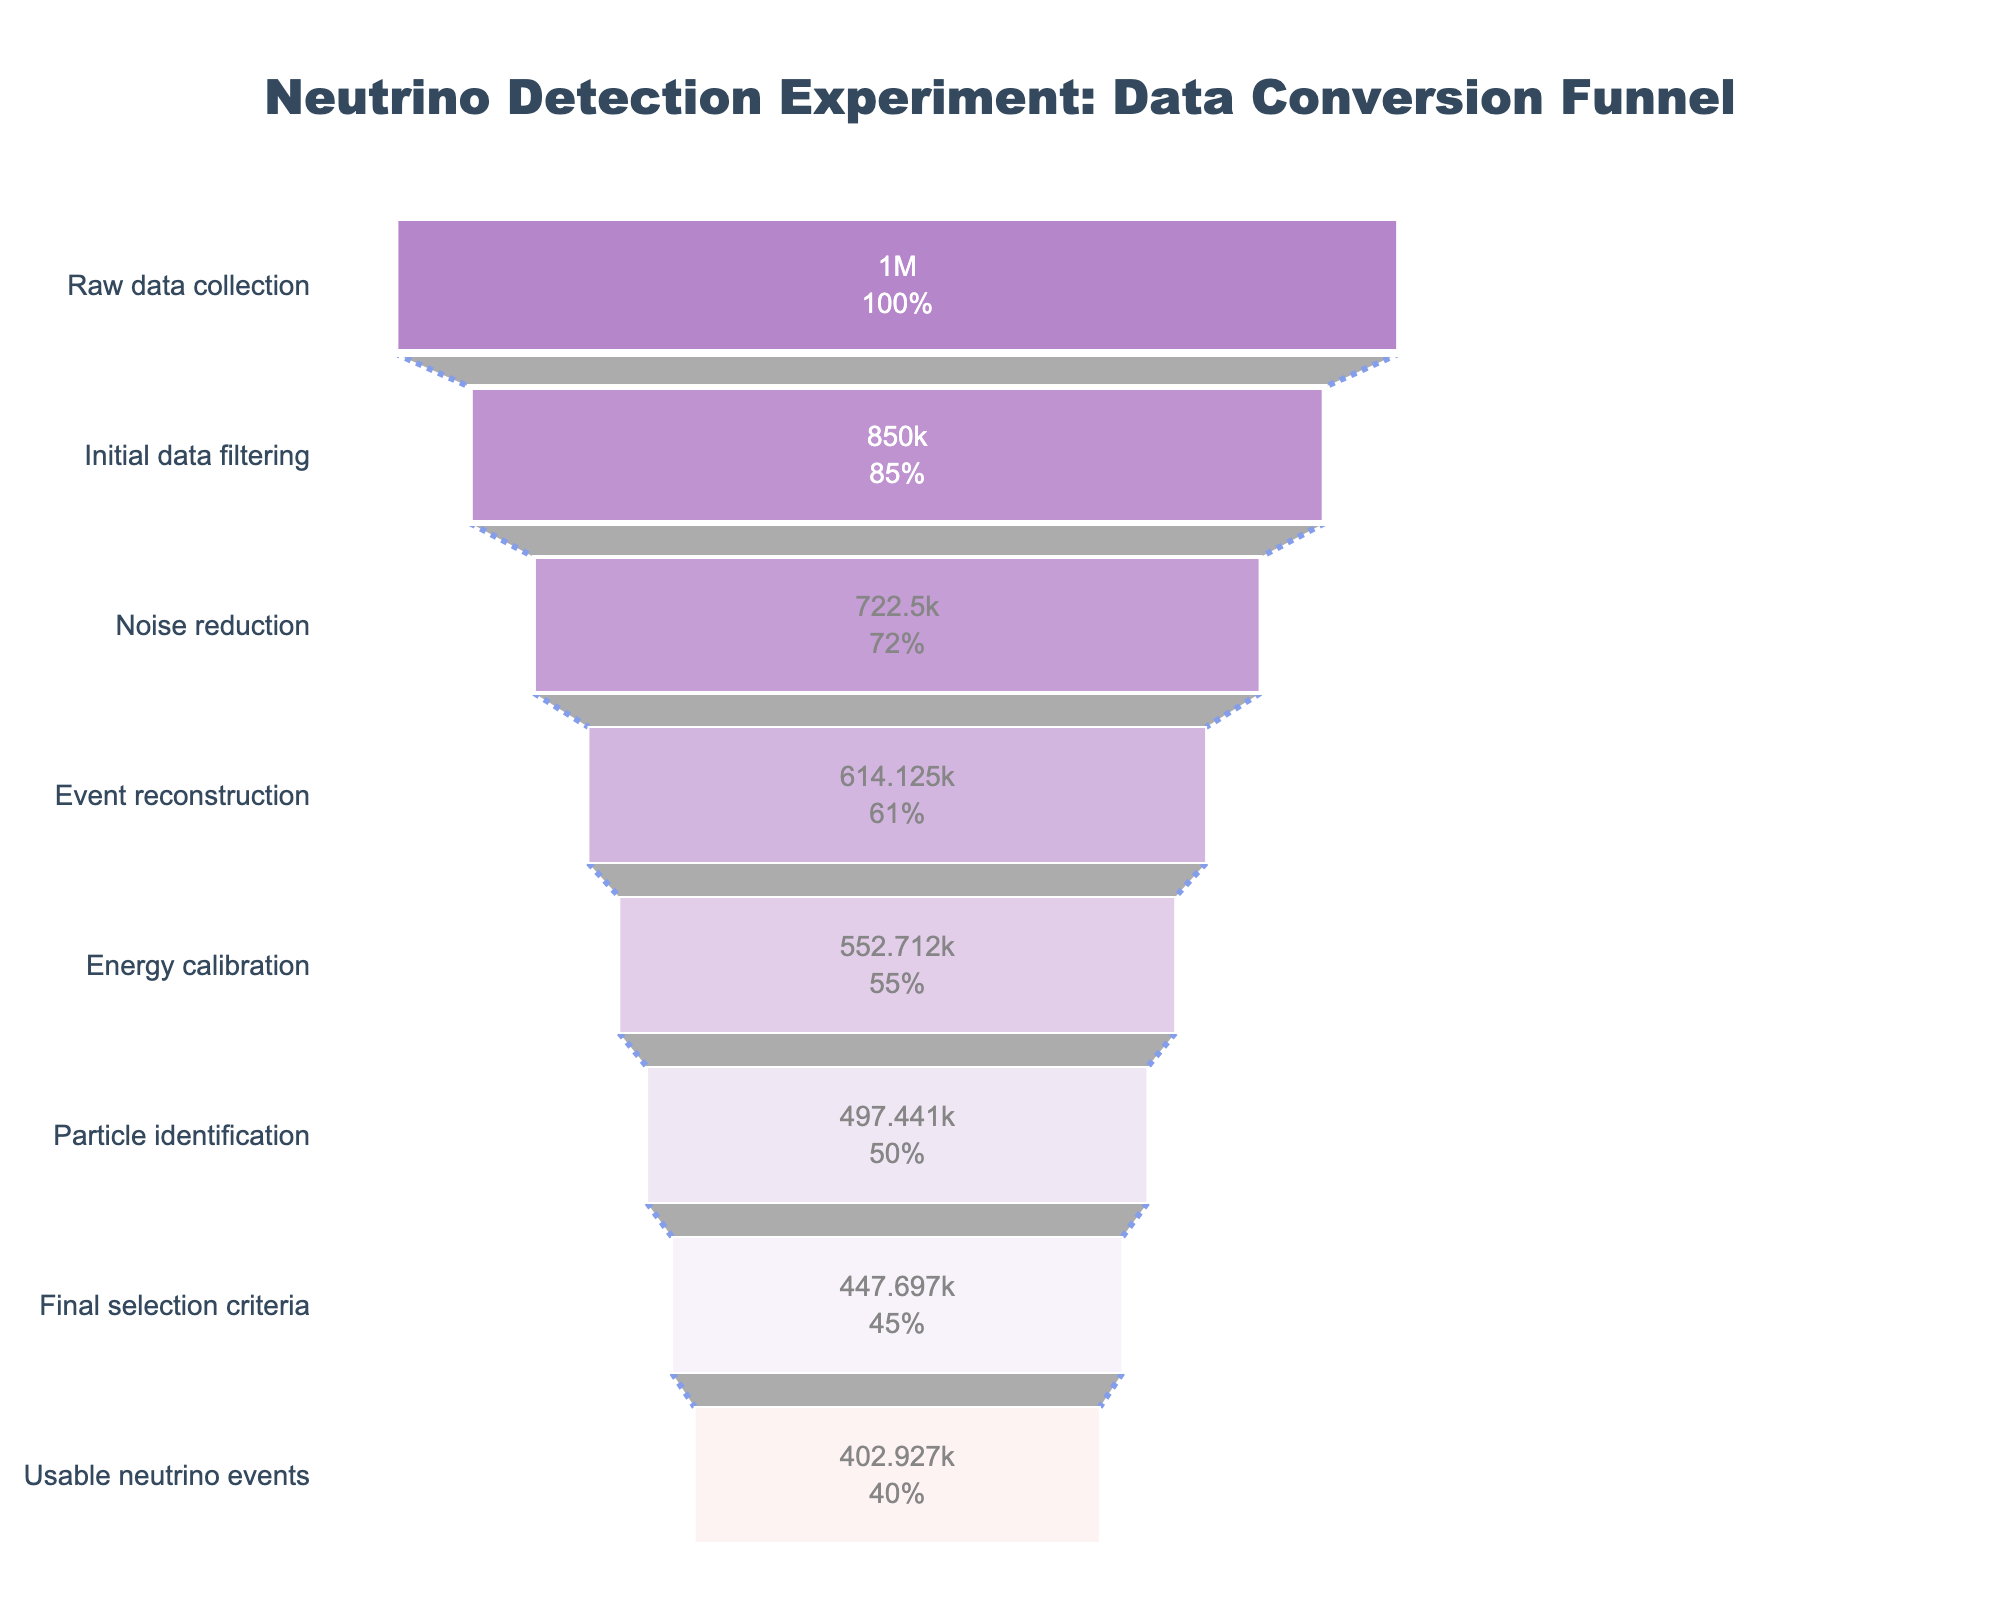what is the percentage of usable neutrino events compared to the raw data collection? To determine this, we can look at the last stage in the funnel chart, which shows the usable neutrino events. The percentage of usable neutrino events is 40.29% as indicated in the chart.
Answer: 40.29% How many events were retained after initial data filtering? According to the funnel chart, after the initial data filtering stage, 850,000 events were retained.
Answer: 850,000 What stage has the largest drop in the number of events? To find this, we need to compare the decrease in events between each successive stage. The drop from raw data collection (1,000,000 events) to initial data filtering (850,000 events) is the largest, resulting in a loss of 150,000 events.
Answer: Initial data filtering What is the total number of events lost from raw data collection to usable neutrino events? The number of events lost is the difference between initial and final stages. From 1,000,000 raw data events to 402,927 usable neutrino events, the difference is 1,000,000 - 402,927 = 597,073 events.
Answer: 597,073 Which stage retains more than half of the initial events? By checking the percentages retained at each stage, the last stage where more than 50% of initial events are retained is Energy Calibration (55.27%). The next stage, Particle Identification, retains less than 50% of the initial events.
Answer: Energy Calibration How many stages are there in the data conversion funnel? The number of stages can be counted from the y-axis labels in the funnel chart. There are 8 stages in total.
Answer: 8 What is the percentage of events retained after the noise reduction stage? The percentage can be read directly from the funnel chart. After noise reduction, 72.25% of the events are retained.
Answer: 72.25% Compare the percentage of events retained after event reconstruction and particle identification. Event reconstruction retains 61.41% of the events, whereas particle identification retains 49.74% of the events.
Answer: Event reconstruction retains more than particle identification If 552,712 events are retained after energy calibration, how many were lost during event reconstruction? The number of events retained from event reconstruction to energy calibration is 614,125 - 552,712 = 61,413.
Answer: 61,413 At which stage does the percentage of retained events first drop below 45%? From the funnel chart, the stage 'Final selection criteria' is the first to have the percentage of retained events below 45%, with 44.77%.
Answer: Final selection criteria 